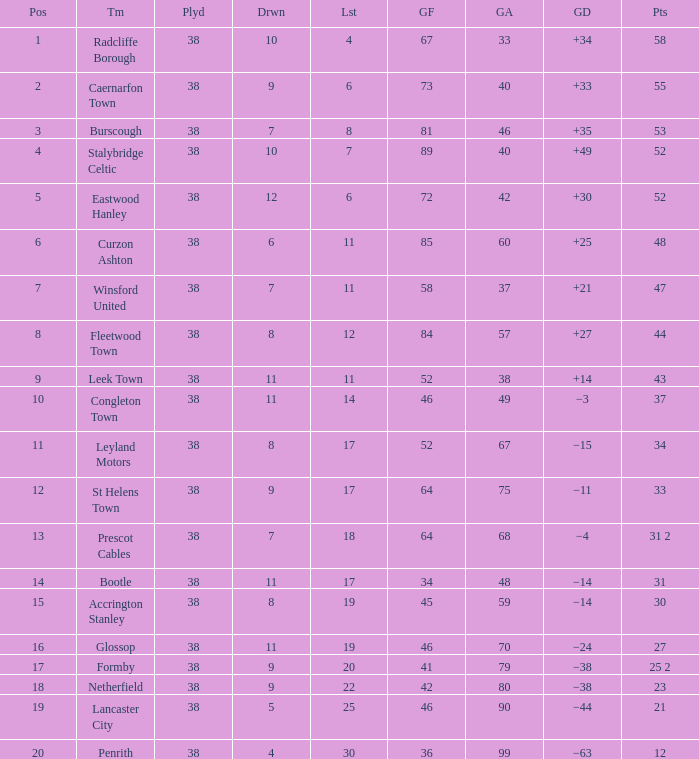WHAT IS THE SUM PLAYED WITH POINTS 1 OF 53, AND POSITION LARGER THAN 3? None. 